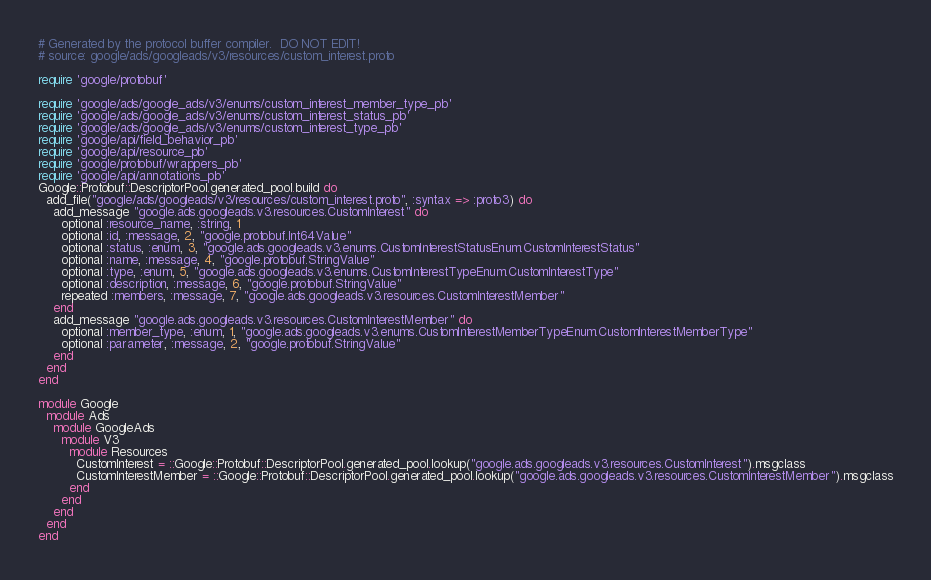Convert code to text. <code><loc_0><loc_0><loc_500><loc_500><_Ruby_># Generated by the protocol buffer compiler.  DO NOT EDIT!
# source: google/ads/googleads/v3/resources/custom_interest.proto

require 'google/protobuf'

require 'google/ads/google_ads/v3/enums/custom_interest_member_type_pb'
require 'google/ads/google_ads/v3/enums/custom_interest_status_pb'
require 'google/ads/google_ads/v3/enums/custom_interest_type_pb'
require 'google/api/field_behavior_pb'
require 'google/api/resource_pb'
require 'google/protobuf/wrappers_pb'
require 'google/api/annotations_pb'
Google::Protobuf::DescriptorPool.generated_pool.build do
  add_file("google/ads/googleads/v3/resources/custom_interest.proto", :syntax => :proto3) do
    add_message "google.ads.googleads.v3.resources.CustomInterest" do
      optional :resource_name, :string, 1
      optional :id, :message, 2, "google.protobuf.Int64Value"
      optional :status, :enum, 3, "google.ads.googleads.v3.enums.CustomInterestStatusEnum.CustomInterestStatus"
      optional :name, :message, 4, "google.protobuf.StringValue"
      optional :type, :enum, 5, "google.ads.googleads.v3.enums.CustomInterestTypeEnum.CustomInterestType"
      optional :description, :message, 6, "google.protobuf.StringValue"
      repeated :members, :message, 7, "google.ads.googleads.v3.resources.CustomInterestMember"
    end
    add_message "google.ads.googleads.v3.resources.CustomInterestMember" do
      optional :member_type, :enum, 1, "google.ads.googleads.v3.enums.CustomInterestMemberTypeEnum.CustomInterestMemberType"
      optional :parameter, :message, 2, "google.protobuf.StringValue"
    end
  end
end

module Google
  module Ads
    module GoogleAds
      module V3
        module Resources
          CustomInterest = ::Google::Protobuf::DescriptorPool.generated_pool.lookup("google.ads.googleads.v3.resources.CustomInterest").msgclass
          CustomInterestMember = ::Google::Protobuf::DescriptorPool.generated_pool.lookup("google.ads.googleads.v3.resources.CustomInterestMember").msgclass
        end
      end
    end
  end
end
</code> 